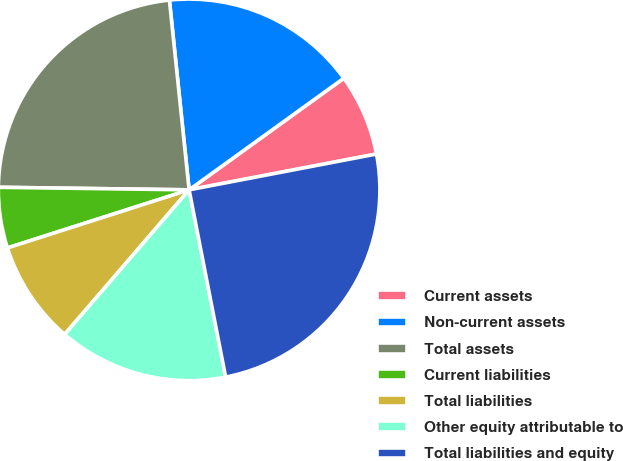Convert chart to OTSL. <chart><loc_0><loc_0><loc_500><loc_500><pie_chart><fcel>Current assets<fcel>Non-current assets<fcel>Total assets<fcel>Current liabilities<fcel>Total liabilities<fcel>Other equity attributable to<fcel>Total liabilities and equity<nl><fcel>6.94%<fcel>16.7%<fcel>23.14%<fcel>5.14%<fcel>8.76%<fcel>14.38%<fcel>24.94%<nl></chart> 